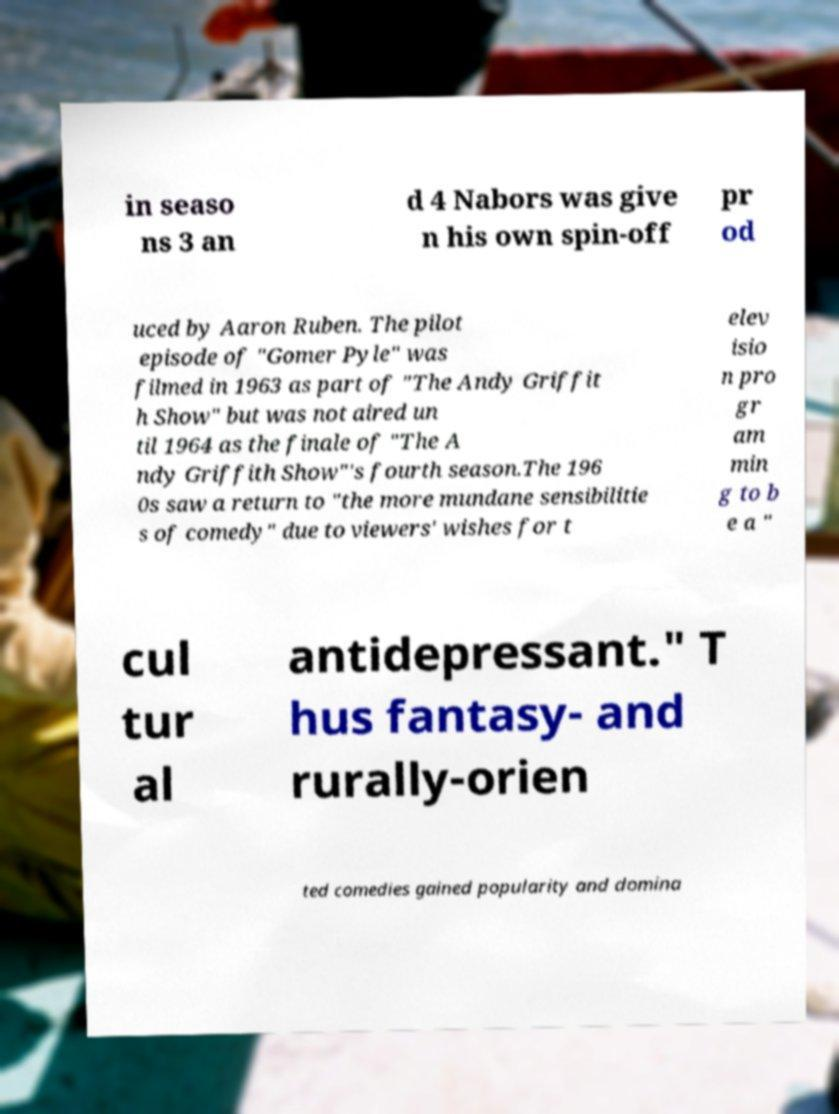Please read and relay the text visible in this image. What does it say? in seaso ns 3 an d 4 Nabors was give n his own spin-off pr od uced by Aaron Ruben. The pilot episode of "Gomer Pyle" was filmed in 1963 as part of "The Andy Griffit h Show" but was not aired un til 1964 as the finale of "The A ndy Griffith Show"'s fourth season.The 196 0s saw a return to "the more mundane sensibilitie s of comedy" due to viewers' wishes for t elev isio n pro gr am min g to b e a " cul tur al antidepressant." T hus fantasy- and rurally-orien ted comedies gained popularity and domina 